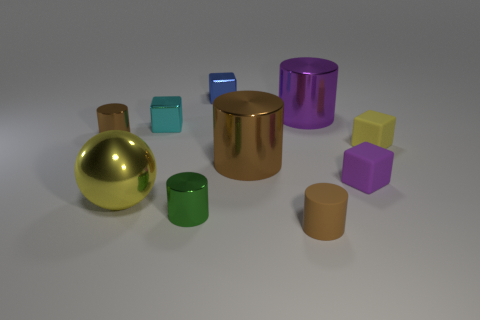Subtract all brown cylinders. How many were subtracted if there are1brown cylinders left? 2 Subtract all yellow blocks. How many brown cylinders are left? 3 Subtract all green shiny cylinders. How many cylinders are left? 4 Subtract all purple cylinders. How many cylinders are left? 4 Subtract all yellow cylinders. Subtract all green cubes. How many cylinders are left? 5 Subtract all cubes. How many objects are left? 6 Add 6 tiny matte cubes. How many tiny matte cubes exist? 8 Subtract 1 blue cubes. How many objects are left? 9 Subtract all big cyan metal blocks. Subtract all small cyan metal cubes. How many objects are left? 9 Add 4 purple things. How many purple things are left? 6 